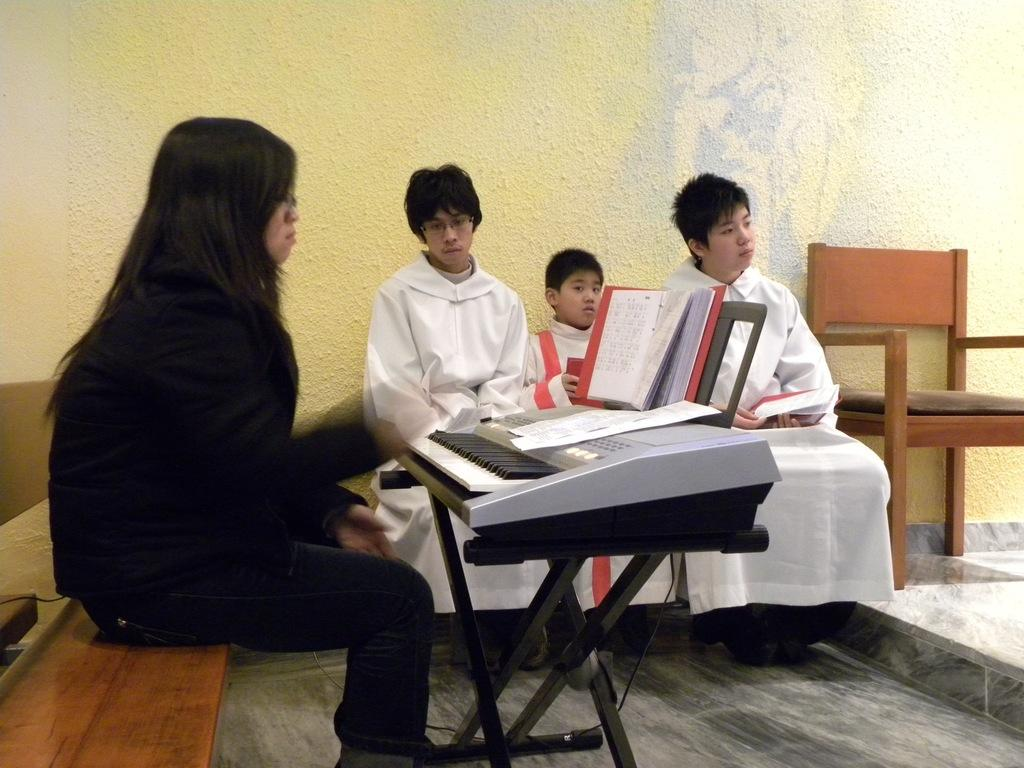What are the people in the image doing? The people in the image are sitting on a bench. Can you describe the woman in the image? There is a woman in the image. What object can be seen in the image besides the bench and the woman? There is a piano in the image. Where is the shelf located in the image? There is no shelf present in the image. What time of day is it in the image, and is there a baby present? The time of day is not mentioned in the image, and there is no baby present. 